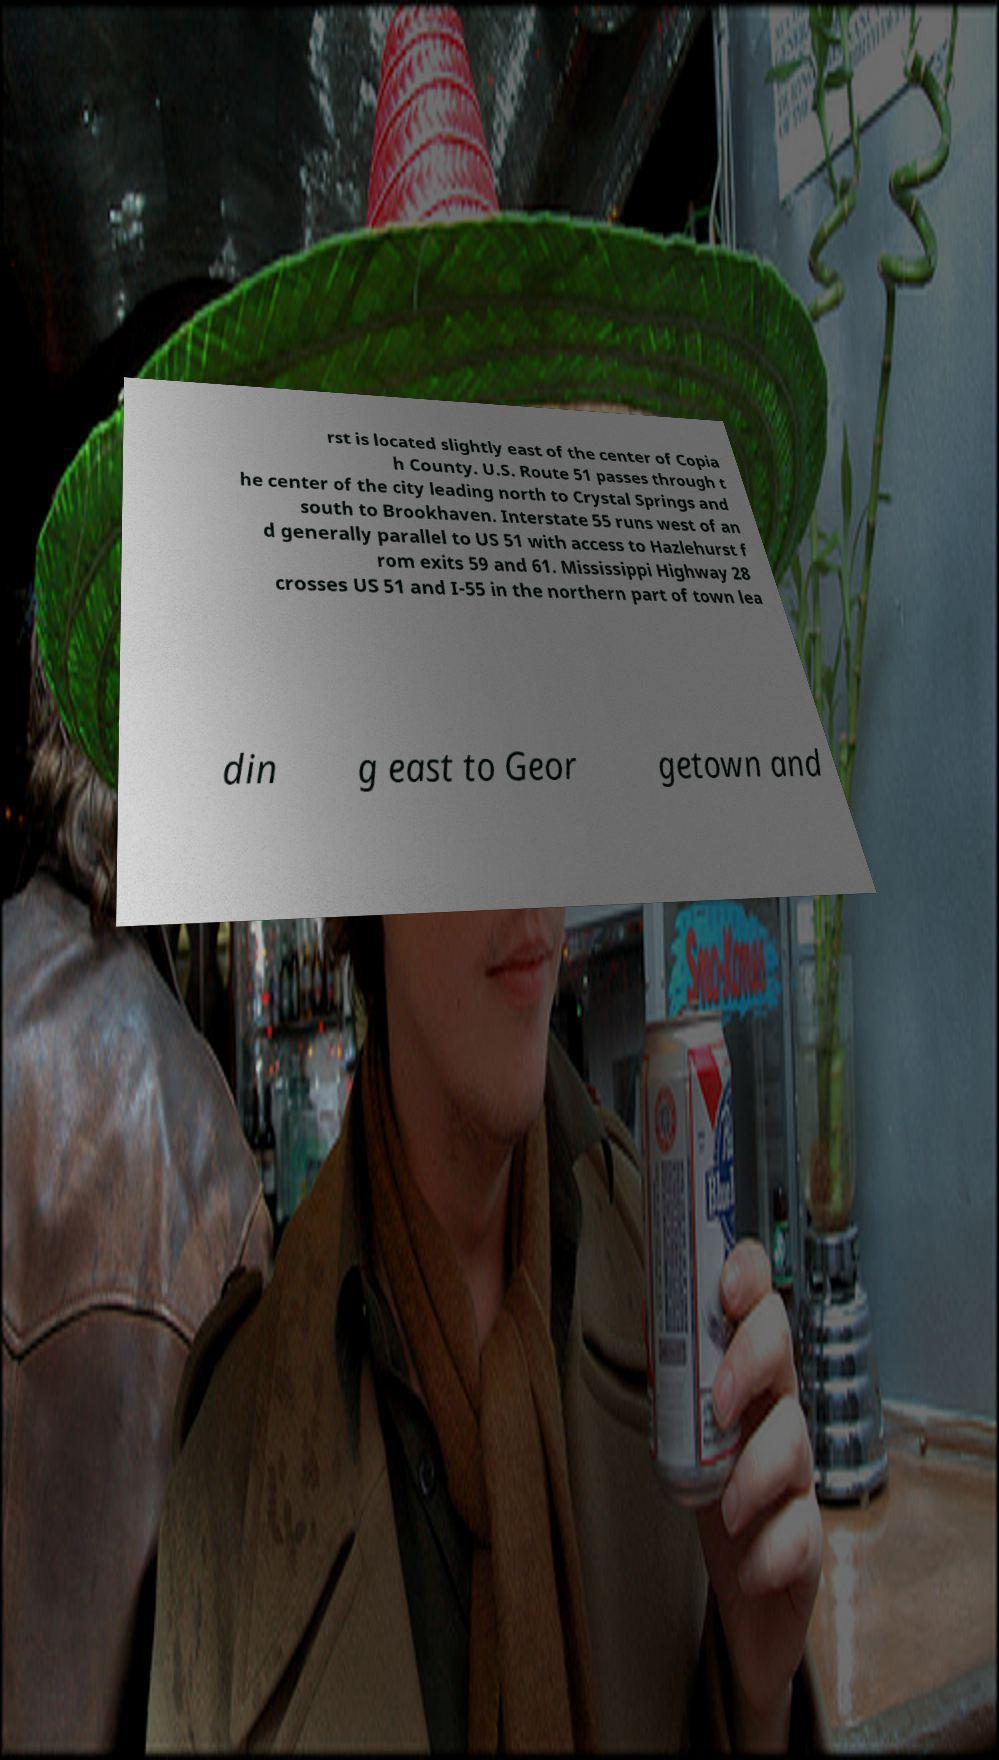I need the written content from this picture converted into text. Can you do that? rst is located slightly east of the center of Copia h County. U.S. Route 51 passes through t he center of the city leading north to Crystal Springs and south to Brookhaven. Interstate 55 runs west of an d generally parallel to US 51 with access to Hazlehurst f rom exits 59 and 61. Mississippi Highway 28 crosses US 51 and I-55 in the northern part of town lea din g east to Geor getown and 